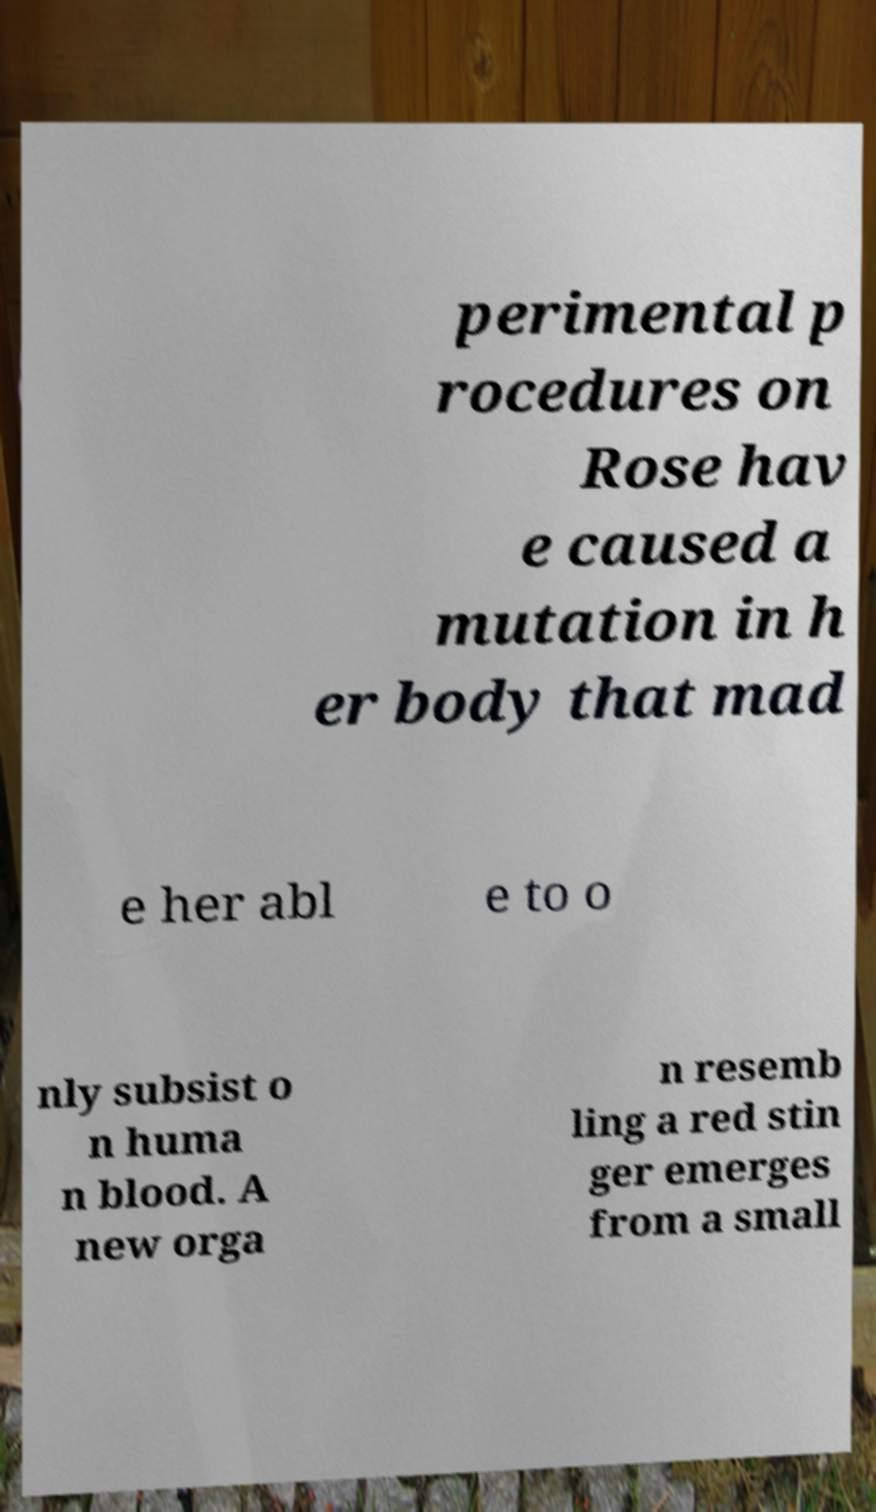Could you assist in decoding the text presented in this image and type it out clearly? perimental p rocedures on Rose hav e caused a mutation in h er body that mad e her abl e to o nly subsist o n huma n blood. A new orga n resemb ling a red stin ger emerges from a small 